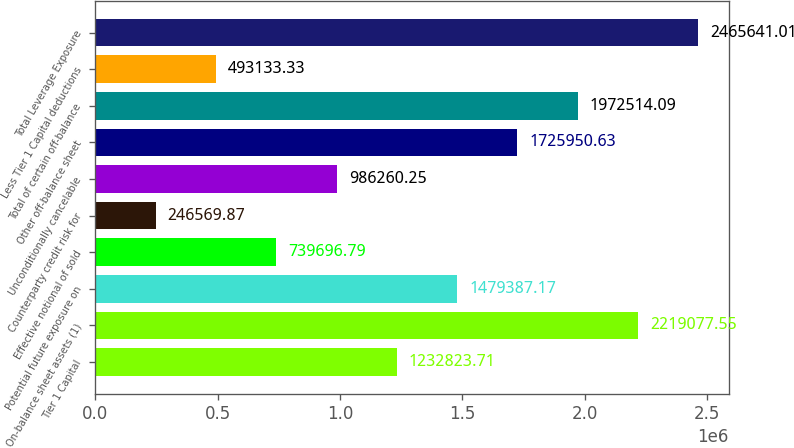Convert chart. <chart><loc_0><loc_0><loc_500><loc_500><bar_chart><fcel>Tier 1 Capital<fcel>On-balance sheet assets (1)<fcel>Potential future exposure on<fcel>Effective notional of sold<fcel>Counterparty credit risk for<fcel>Unconditionally cancelable<fcel>Other off-balance sheet<fcel>Total of certain off-balance<fcel>Less Tier 1 Capital deductions<fcel>Total Leverage Exposure<nl><fcel>1.23282e+06<fcel>2.21908e+06<fcel>1.47939e+06<fcel>739697<fcel>246570<fcel>986260<fcel>1.72595e+06<fcel>1.97251e+06<fcel>493133<fcel>2.46564e+06<nl></chart> 